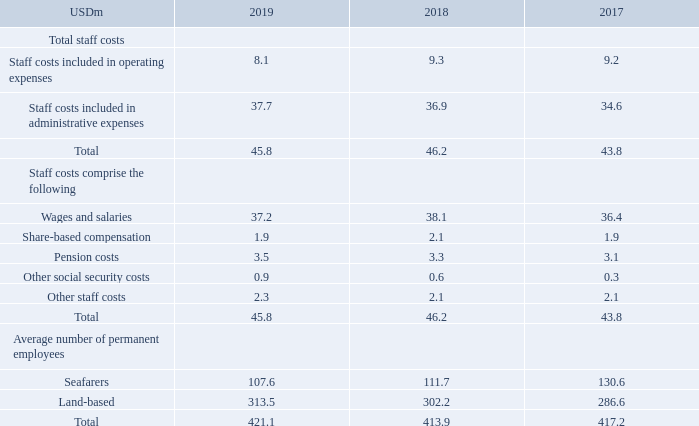NOTE 3 – STAFF COSTS
Employee information
The majority of the staff on vessels are not employed by TORM. Staff costs included in operating expenses relate to the 108 seafarers (2018: 112, 2017: 131).
The average number of employees is calculated as a full-time equivalent (FTE).
The Executive Director is, in the event of termination by the Company, entitled to a severance payment of up to 12 months' salary.
What are the staff costs included in operating expenses related to? The 108 seafarers (2018: 112, 2017: 131). How is the average number of employees calculated? As a full-time equivalent (fte). What do the staff costs comprise of? Wages and salaries, share-based compensation, pension costs, other social security costs, other staff costs. In which year was the pension costs the largest? 3.5>3.3>3.1
Answer: 2019. What was the change in the total number of permanent employees from 2018 to 2019?
Answer scale should be: million. 421.1-413.9
Answer: 7.2. What was the percentage change in the total number of permanent employees from 2018 to 2019?
Answer scale should be: percent. (421.1-413.9)/413.9
Answer: 1.74. 